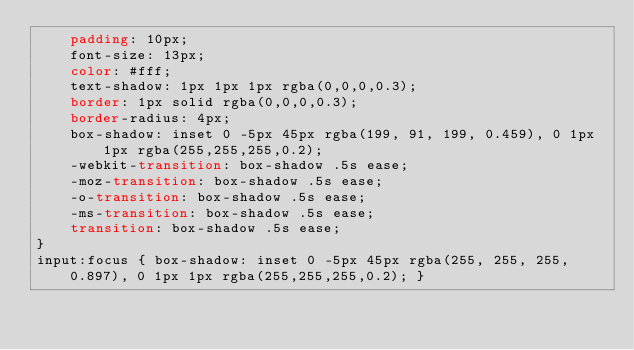<code> <loc_0><loc_0><loc_500><loc_500><_CSS_>    padding: 10px;
    font-size: 13px;
    color: #fff;
    text-shadow: 1px 1px 1px rgba(0,0,0,0.3);
    border: 1px solid rgba(0,0,0,0.3);
    border-radius: 4px;
    box-shadow: inset 0 -5px 45px rgba(199, 91, 199, 0.459), 0 1px 1px rgba(255,255,255,0.2);
    -webkit-transition: box-shadow .5s ease;
    -moz-transition: box-shadow .5s ease;
    -o-transition: box-shadow .5s ease;
    -ms-transition: box-shadow .5s ease;
    transition: box-shadow .5s ease;
}
input:focus { box-shadow: inset 0 -5px 45px rgba(255, 255, 255, 0.897), 0 1px 1px rgba(255,255,255,0.2); }</code> 